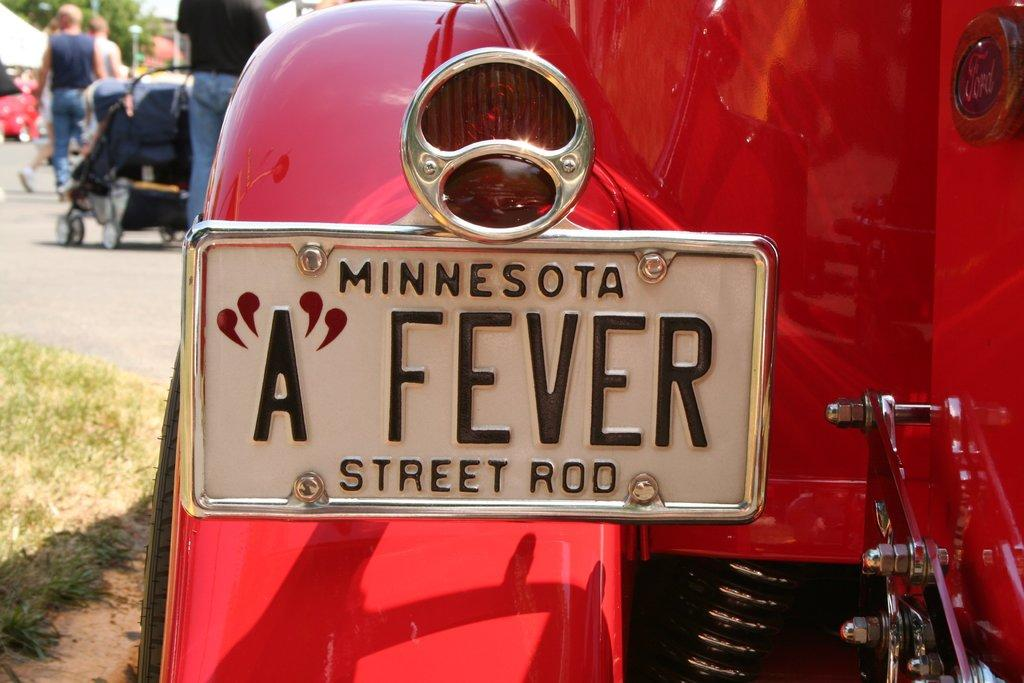What is located in the foreground of the image? In the foreground of the image, there is a car, a nameplate, grass, and an indicator light. What can be seen towards the left at the top of the image? Towards the left at the top of the image, there are people, a stroller, a tent, more people, a road, and other objects. Can you describe the car in the foreground? The car in the foreground is a specific model, as indicated by the nameplate. What type of surface is visible in the foreground? The grass in the foreground suggests that the car is parked on a grassy area. What type of bead is being used to control the reaction of the fowl in the image? There is no bead or fowl present in the image. How does the reaction of the fowl affect the people in the image? There is no fowl or reaction to be observed in the image. 